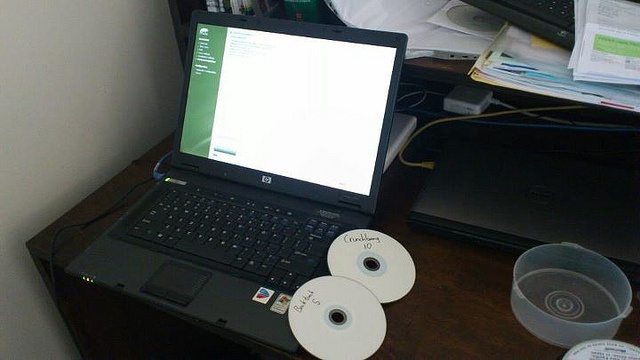Describe the objects in this image and their specific colors. I can see a laptop in darkgray, black, white, green, and navy tones in this image. 